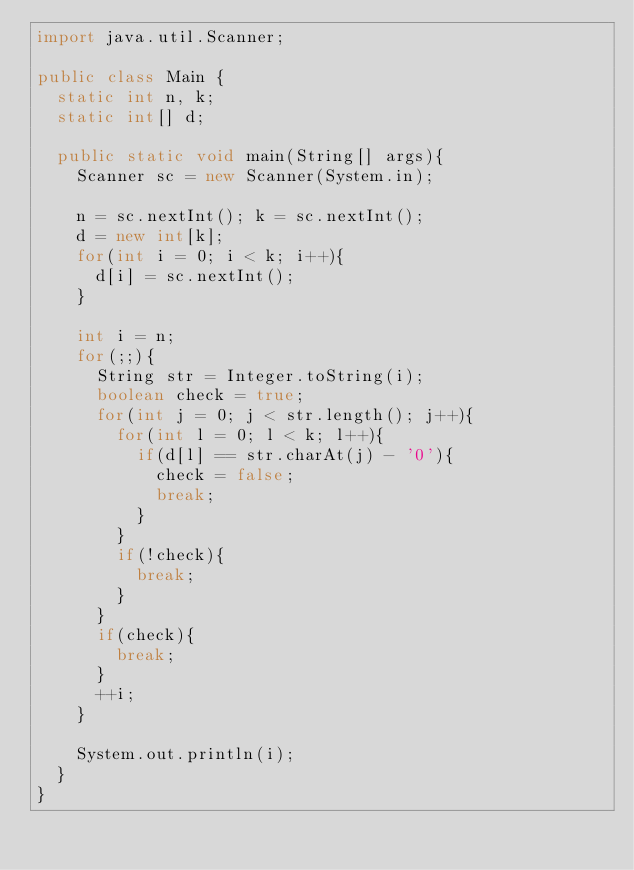Convert code to text. <code><loc_0><loc_0><loc_500><loc_500><_Java_>import java.util.Scanner;

public class Main {
  static int n, k;
  static int[] d;

  public static void main(String[] args){
    Scanner sc = new Scanner(System.in);

    n = sc.nextInt(); k = sc.nextInt();
    d = new int[k];
    for(int i = 0; i < k; i++){
      d[i] = sc.nextInt();
    }

    int i = n;
    for(;;){
      String str = Integer.toString(i);
      boolean check = true;
      for(int j = 0; j < str.length(); j++){
        for(int l = 0; l < k; l++){
          if(d[l] == str.charAt(j) - '0'){
            check = false;
            break;
          }
        }
        if(!check){
          break;
        }
      }
      if(check){
        break;
      }
      ++i;
    }

    System.out.println(i);
  }
}
</code> 